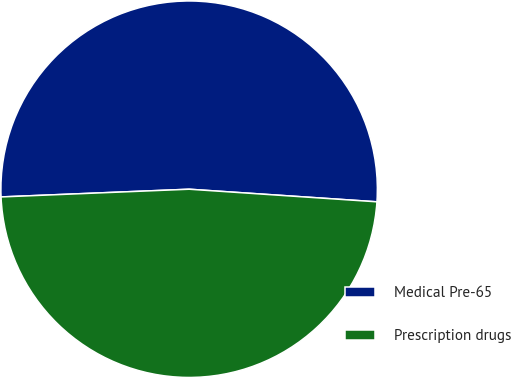Convert chart to OTSL. <chart><loc_0><loc_0><loc_500><loc_500><pie_chart><fcel>Medical Pre-65<fcel>Prescription drugs<nl><fcel>51.72%<fcel>48.28%<nl></chart> 